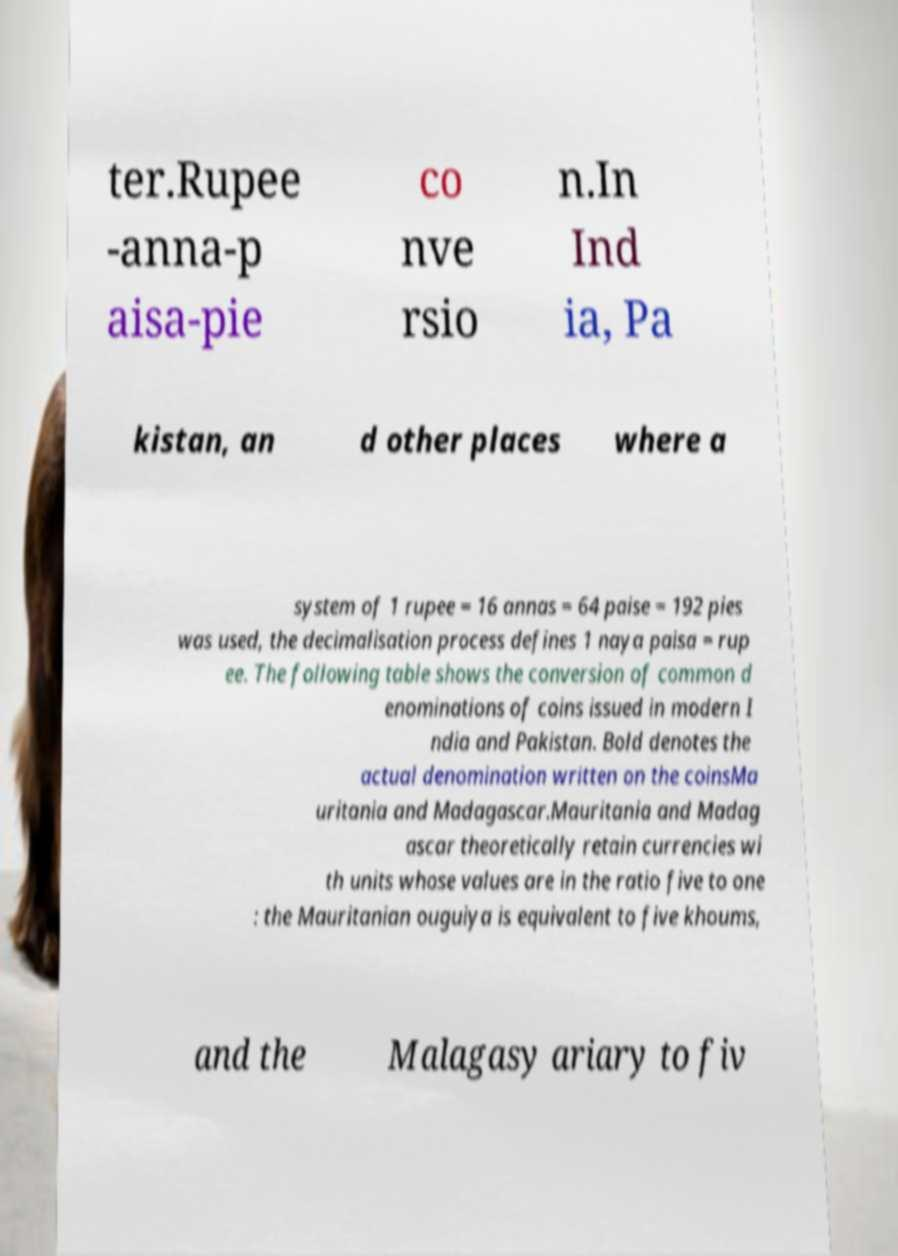Please identify and transcribe the text found in this image. ter.Rupee -anna-p aisa-pie co nve rsio n.In Ind ia, Pa kistan, an d other places where a system of 1 rupee = 16 annas = 64 paise = 192 pies was used, the decimalisation process defines 1 naya paisa = rup ee. The following table shows the conversion of common d enominations of coins issued in modern I ndia and Pakistan. Bold denotes the actual denomination written on the coinsMa uritania and Madagascar.Mauritania and Madag ascar theoretically retain currencies wi th units whose values are in the ratio five to one : the Mauritanian ouguiya is equivalent to five khoums, and the Malagasy ariary to fiv 